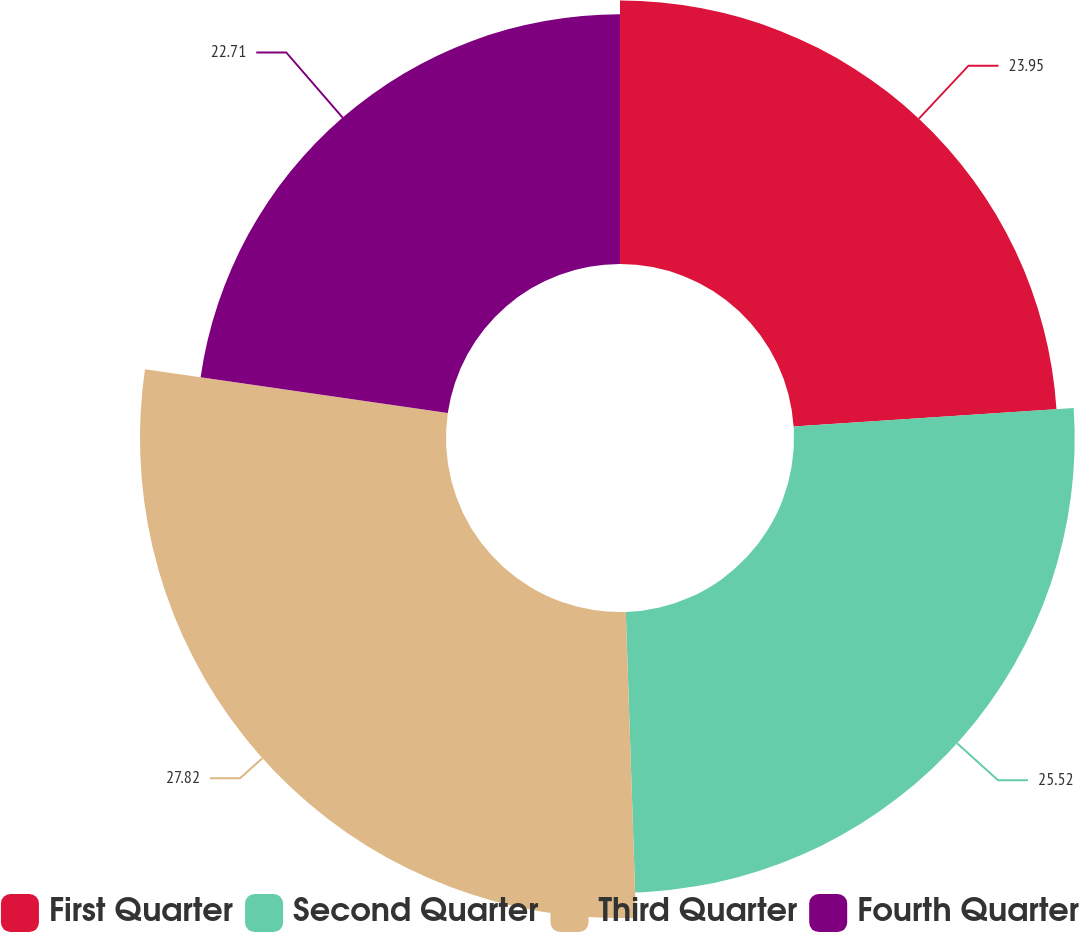Convert chart. <chart><loc_0><loc_0><loc_500><loc_500><pie_chart><fcel>First Quarter<fcel>Second Quarter<fcel>Third Quarter<fcel>Fourth Quarter<nl><fcel>23.95%<fcel>25.52%<fcel>27.82%<fcel>22.71%<nl></chart> 